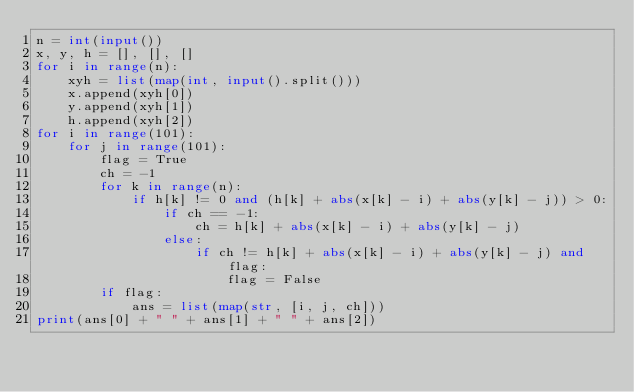Convert code to text. <code><loc_0><loc_0><loc_500><loc_500><_Python_>n = int(input())
x, y, h = [], [], []
for i in range(n):
    xyh = list(map(int, input().split()))
    x.append(xyh[0])
    y.append(xyh[1])
    h.append(xyh[2])
for i in range(101):
    for j in range(101):
        flag = True
        ch = -1
        for k in range(n):
            if h[k] != 0 and (h[k] + abs(x[k] - i) + abs(y[k] - j)) > 0:
                if ch == -1:
                    ch = h[k] + abs(x[k] - i) + abs(y[k] - j)
                else:
                    if ch != h[k] + abs(x[k] - i) + abs(y[k] - j) and flag:
                        flag = False
        if flag:
            ans = list(map(str, [i, j, ch]))
print(ans[0] + " " + ans[1] + " " + ans[2])
</code> 